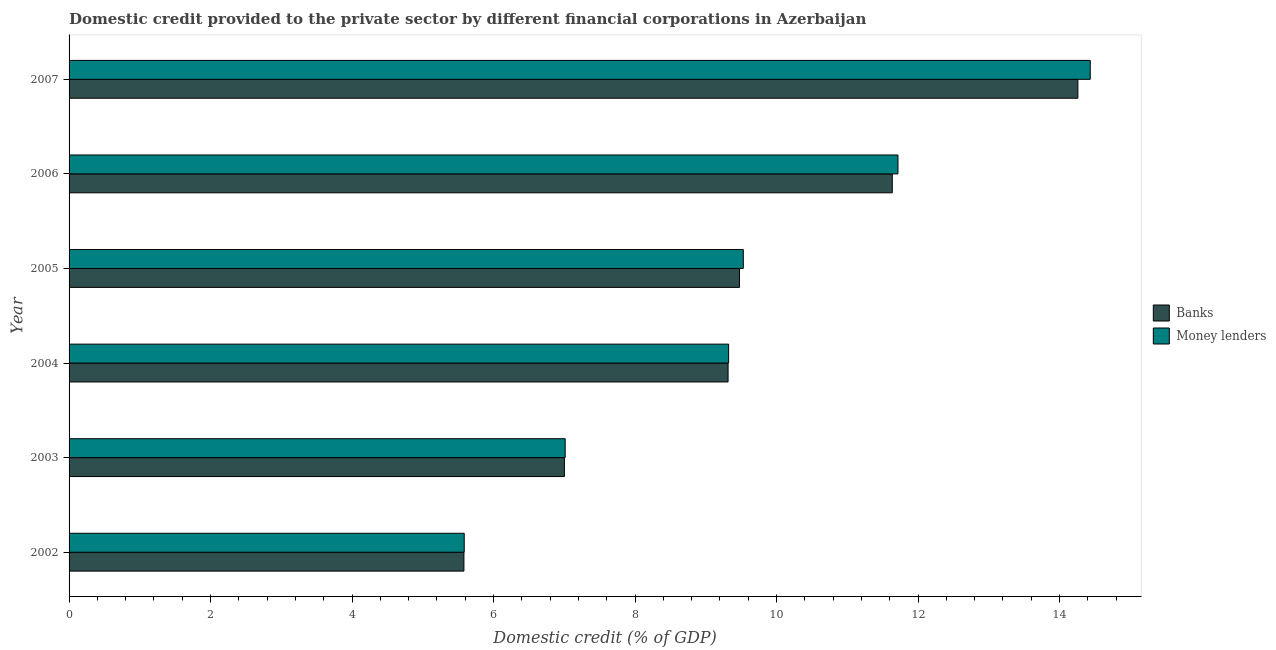How many groups of bars are there?
Provide a succinct answer. 6. Are the number of bars on each tick of the Y-axis equal?
Ensure brevity in your answer.  Yes. How many bars are there on the 3rd tick from the top?
Give a very brief answer. 2. In how many cases, is the number of bars for a given year not equal to the number of legend labels?
Your answer should be compact. 0. What is the domestic credit provided by money lenders in 2006?
Your answer should be very brief. 11.72. Across all years, what is the maximum domestic credit provided by banks?
Keep it short and to the point. 14.26. Across all years, what is the minimum domestic credit provided by money lenders?
Your answer should be very brief. 5.58. What is the total domestic credit provided by banks in the graph?
Offer a terse response. 57.27. What is the difference between the domestic credit provided by money lenders in 2002 and that in 2003?
Provide a short and direct response. -1.43. What is the difference between the domestic credit provided by banks in 2003 and the domestic credit provided by money lenders in 2006?
Give a very brief answer. -4.71. What is the average domestic credit provided by banks per year?
Give a very brief answer. 9.54. In the year 2003, what is the difference between the domestic credit provided by money lenders and domestic credit provided by banks?
Your answer should be very brief. 0.01. In how many years, is the domestic credit provided by money lenders greater than 2 %?
Your answer should be compact. 6. What is the ratio of the domestic credit provided by money lenders in 2003 to that in 2005?
Provide a succinct answer. 0.74. Is the difference between the domestic credit provided by banks in 2002 and 2006 greater than the difference between the domestic credit provided by money lenders in 2002 and 2006?
Provide a succinct answer. Yes. What is the difference between the highest and the second highest domestic credit provided by banks?
Your response must be concise. 2.62. What is the difference between the highest and the lowest domestic credit provided by banks?
Offer a terse response. 8.68. In how many years, is the domestic credit provided by money lenders greater than the average domestic credit provided by money lenders taken over all years?
Your answer should be compact. 2. Is the sum of the domestic credit provided by banks in 2002 and 2007 greater than the maximum domestic credit provided by money lenders across all years?
Offer a terse response. Yes. What does the 1st bar from the top in 2006 represents?
Make the answer very short. Money lenders. What does the 1st bar from the bottom in 2007 represents?
Your answer should be compact. Banks. How many bars are there?
Offer a very short reply. 12. How many years are there in the graph?
Your answer should be compact. 6. Are the values on the major ticks of X-axis written in scientific E-notation?
Offer a terse response. No. How many legend labels are there?
Offer a very short reply. 2. How are the legend labels stacked?
Ensure brevity in your answer.  Vertical. What is the title of the graph?
Your response must be concise. Domestic credit provided to the private sector by different financial corporations in Azerbaijan. What is the label or title of the X-axis?
Ensure brevity in your answer.  Domestic credit (% of GDP). What is the Domestic credit (% of GDP) of Banks in 2002?
Provide a short and direct response. 5.58. What is the Domestic credit (% of GDP) in Money lenders in 2002?
Ensure brevity in your answer.  5.58. What is the Domestic credit (% of GDP) of Banks in 2003?
Your answer should be compact. 7. What is the Domestic credit (% of GDP) in Money lenders in 2003?
Make the answer very short. 7.01. What is the Domestic credit (% of GDP) of Banks in 2004?
Your response must be concise. 9.31. What is the Domestic credit (% of GDP) of Money lenders in 2004?
Keep it short and to the point. 9.32. What is the Domestic credit (% of GDP) of Banks in 2005?
Give a very brief answer. 9.48. What is the Domestic credit (% of GDP) of Money lenders in 2005?
Make the answer very short. 9.53. What is the Domestic credit (% of GDP) in Banks in 2006?
Provide a short and direct response. 11.64. What is the Domestic credit (% of GDP) of Money lenders in 2006?
Provide a succinct answer. 11.72. What is the Domestic credit (% of GDP) in Banks in 2007?
Keep it short and to the point. 14.26. What is the Domestic credit (% of GDP) of Money lenders in 2007?
Your answer should be compact. 14.43. Across all years, what is the maximum Domestic credit (% of GDP) of Banks?
Your answer should be compact. 14.26. Across all years, what is the maximum Domestic credit (% of GDP) in Money lenders?
Your answer should be very brief. 14.43. Across all years, what is the minimum Domestic credit (% of GDP) of Banks?
Keep it short and to the point. 5.58. Across all years, what is the minimum Domestic credit (% of GDP) in Money lenders?
Your answer should be very brief. 5.58. What is the total Domestic credit (% of GDP) in Banks in the graph?
Your response must be concise. 57.27. What is the total Domestic credit (% of GDP) in Money lenders in the graph?
Your answer should be very brief. 57.6. What is the difference between the Domestic credit (% of GDP) in Banks in 2002 and that in 2003?
Ensure brevity in your answer.  -1.42. What is the difference between the Domestic credit (% of GDP) in Money lenders in 2002 and that in 2003?
Your answer should be compact. -1.43. What is the difference between the Domestic credit (% of GDP) in Banks in 2002 and that in 2004?
Ensure brevity in your answer.  -3.73. What is the difference between the Domestic credit (% of GDP) of Money lenders in 2002 and that in 2004?
Make the answer very short. -3.74. What is the difference between the Domestic credit (% of GDP) of Banks in 2002 and that in 2005?
Ensure brevity in your answer.  -3.89. What is the difference between the Domestic credit (% of GDP) in Money lenders in 2002 and that in 2005?
Provide a short and direct response. -3.94. What is the difference between the Domestic credit (% of GDP) in Banks in 2002 and that in 2006?
Your answer should be compact. -6.05. What is the difference between the Domestic credit (% of GDP) in Money lenders in 2002 and that in 2006?
Offer a very short reply. -6.13. What is the difference between the Domestic credit (% of GDP) of Banks in 2002 and that in 2007?
Ensure brevity in your answer.  -8.68. What is the difference between the Domestic credit (% of GDP) in Money lenders in 2002 and that in 2007?
Give a very brief answer. -8.85. What is the difference between the Domestic credit (% of GDP) of Banks in 2003 and that in 2004?
Make the answer very short. -2.31. What is the difference between the Domestic credit (% of GDP) of Money lenders in 2003 and that in 2004?
Ensure brevity in your answer.  -2.31. What is the difference between the Domestic credit (% of GDP) of Banks in 2003 and that in 2005?
Give a very brief answer. -2.47. What is the difference between the Domestic credit (% of GDP) of Money lenders in 2003 and that in 2005?
Give a very brief answer. -2.52. What is the difference between the Domestic credit (% of GDP) of Banks in 2003 and that in 2006?
Ensure brevity in your answer.  -4.63. What is the difference between the Domestic credit (% of GDP) of Money lenders in 2003 and that in 2006?
Offer a very short reply. -4.7. What is the difference between the Domestic credit (% of GDP) in Banks in 2003 and that in 2007?
Provide a short and direct response. -7.26. What is the difference between the Domestic credit (% of GDP) in Money lenders in 2003 and that in 2007?
Offer a very short reply. -7.42. What is the difference between the Domestic credit (% of GDP) of Banks in 2004 and that in 2005?
Offer a terse response. -0.16. What is the difference between the Domestic credit (% of GDP) of Money lenders in 2004 and that in 2005?
Make the answer very short. -0.21. What is the difference between the Domestic credit (% of GDP) of Banks in 2004 and that in 2006?
Keep it short and to the point. -2.32. What is the difference between the Domestic credit (% of GDP) in Money lenders in 2004 and that in 2006?
Make the answer very short. -2.39. What is the difference between the Domestic credit (% of GDP) of Banks in 2004 and that in 2007?
Offer a terse response. -4.94. What is the difference between the Domestic credit (% of GDP) of Money lenders in 2004 and that in 2007?
Provide a succinct answer. -5.11. What is the difference between the Domestic credit (% of GDP) of Banks in 2005 and that in 2006?
Your response must be concise. -2.16. What is the difference between the Domestic credit (% of GDP) of Money lenders in 2005 and that in 2006?
Ensure brevity in your answer.  -2.19. What is the difference between the Domestic credit (% of GDP) in Banks in 2005 and that in 2007?
Give a very brief answer. -4.78. What is the difference between the Domestic credit (% of GDP) in Money lenders in 2005 and that in 2007?
Your answer should be very brief. -4.9. What is the difference between the Domestic credit (% of GDP) in Banks in 2006 and that in 2007?
Offer a very short reply. -2.62. What is the difference between the Domestic credit (% of GDP) in Money lenders in 2006 and that in 2007?
Offer a terse response. -2.72. What is the difference between the Domestic credit (% of GDP) in Banks in 2002 and the Domestic credit (% of GDP) in Money lenders in 2003?
Give a very brief answer. -1.43. What is the difference between the Domestic credit (% of GDP) of Banks in 2002 and the Domestic credit (% of GDP) of Money lenders in 2004?
Make the answer very short. -3.74. What is the difference between the Domestic credit (% of GDP) in Banks in 2002 and the Domestic credit (% of GDP) in Money lenders in 2005?
Offer a terse response. -3.95. What is the difference between the Domestic credit (% of GDP) in Banks in 2002 and the Domestic credit (% of GDP) in Money lenders in 2006?
Give a very brief answer. -6.13. What is the difference between the Domestic credit (% of GDP) of Banks in 2002 and the Domestic credit (% of GDP) of Money lenders in 2007?
Offer a terse response. -8.85. What is the difference between the Domestic credit (% of GDP) in Banks in 2003 and the Domestic credit (% of GDP) in Money lenders in 2004?
Your answer should be compact. -2.32. What is the difference between the Domestic credit (% of GDP) in Banks in 2003 and the Domestic credit (% of GDP) in Money lenders in 2005?
Your response must be concise. -2.53. What is the difference between the Domestic credit (% of GDP) of Banks in 2003 and the Domestic credit (% of GDP) of Money lenders in 2006?
Provide a succinct answer. -4.71. What is the difference between the Domestic credit (% of GDP) of Banks in 2003 and the Domestic credit (% of GDP) of Money lenders in 2007?
Provide a short and direct response. -7.43. What is the difference between the Domestic credit (% of GDP) in Banks in 2004 and the Domestic credit (% of GDP) in Money lenders in 2005?
Provide a succinct answer. -0.22. What is the difference between the Domestic credit (% of GDP) in Banks in 2004 and the Domestic credit (% of GDP) in Money lenders in 2006?
Offer a very short reply. -2.4. What is the difference between the Domestic credit (% of GDP) of Banks in 2004 and the Domestic credit (% of GDP) of Money lenders in 2007?
Offer a terse response. -5.12. What is the difference between the Domestic credit (% of GDP) of Banks in 2005 and the Domestic credit (% of GDP) of Money lenders in 2006?
Provide a succinct answer. -2.24. What is the difference between the Domestic credit (% of GDP) of Banks in 2005 and the Domestic credit (% of GDP) of Money lenders in 2007?
Your answer should be very brief. -4.96. What is the difference between the Domestic credit (% of GDP) of Banks in 2006 and the Domestic credit (% of GDP) of Money lenders in 2007?
Keep it short and to the point. -2.8. What is the average Domestic credit (% of GDP) in Banks per year?
Your response must be concise. 9.54. What is the average Domestic credit (% of GDP) of Money lenders per year?
Make the answer very short. 9.6. In the year 2002, what is the difference between the Domestic credit (% of GDP) in Banks and Domestic credit (% of GDP) in Money lenders?
Your response must be concise. -0. In the year 2003, what is the difference between the Domestic credit (% of GDP) in Banks and Domestic credit (% of GDP) in Money lenders?
Your answer should be compact. -0.01. In the year 2004, what is the difference between the Domestic credit (% of GDP) in Banks and Domestic credit (% of GDP) in Money lenders?
Keep it short and to the point. -0.01. In the year 2005, what is the difference between the Domestic credit (% of GDP) of Banks and Domestic credit (% of GDP) of Money lenders?
Make the answer very short. -0.05. In the year 2006, what is the difference between the Domestic credit (% of GDP) of Banks and Domestic credit (% of GDP) of Money lenders?
Your answer should be compact. -0.08. In the year 2007, what is the difference between the Domestic credit (% of GDP) in Banks and Domestic credit (% of GDP) in Money lenders?
Make the answer very short. -0.17. What is the ratio of the Domestic credit (% of GDP) in Banks in 2002 to that in 2003?
Offer a very short reply. 0.8. What is the ratio of the Domestic credit (% of GDP) of Money lenders in 2002 to that in 2003?
Provide a short and direct response. 0.8. What is the ratio of the Domestic credit (% of GDP) of Banks in 2002 to that in 2004?
Ensure brevity in your answer.  0.6. What is the ratio of the Domestic credit (% of GDP) in Money lenders in 2002 to that in 2004?
Keep it short and to the point. 0.6. What is the ratio of the Domestic credit (% of GDP) of Banks in 2002 to that in 2005?
Ensure brevity in your answer.  0.59. What is the ratio of the Domestic credit (% of GDP) in Money lenders in 2002 to that in 2005?
Make the answer very short. 0.59. What is the ratio of the Domestic credit (% of GDP) of Banks in 2002 to that in 2006?
Offer a very short reply. 0.48. What is the ratio of the Domestic credit (% of GDP) in Money lenders in 2002 to that in 2006?
Offer a very short reply. 0.48. What is the ratio of the Domestic credit (% of GDP) in Banks in 2002 to that in 2007?
Offer a very short reply. 0.39. What is the ratio of the Domestic credit (% of GDP) of Money lenders in 2002 to that in 2007?
Provide a succinct answer. 0.39. What is the ratio of the Domestic credit (% of GDP) in Banks in 2003 to that in 2004?
Ensure brevity in your answer.  0.75. What is the ratio of the Domestic credit (% of GDP) in Money lenders in 2003 to that in 2004?
Keep it short and to the point. 0.75. What is the ratio of the Domestic credit (% of GDP) of Banks in 2003 to that in 2005?
Give a very brief answer. 0.74. What is the ratio of the Domestic credit (% of GDP) in Money lenders in 2003 to that in 2005?
Give a very brief answer. 0.74. What is the ratio of the Domestic credit (% of GDP) in Banks in 2003 to that in 2006?
Make the answer very short. 0.6. What is the ratio of the Domestic credit (% of GDP) in Money lenders in 2003 to that in 2006?
Your answer should be compact. 0.6. What is the ratio of the Domestic credit (% of GDP) in Banks in 2003 to that in 2007?
Provide a succinct answer. 0.49. What is the ratio of the Domestic credit (% of GDP) in Money lenders in 2003 to that in 2007?
Offer a terse response. 0.49. What is the ratio of the Domestic credit (% of GDP) in Money lenders in 2004 to that in 2005?
Offer a terse response. 0.98. What is the ratio of the Domestic credit (% of GDP) of Banks in 2004 to that in 2006?
Offer a very short reply. 0.8. What is the ratio of the Domestic credit (% of GDP) of Money lenders in 2004 to that in 2006?
Offer a very short reply. 0.8. What is the ratio of the Domestic credit (% of GDP) in Banks in 2004 to that in 2007?
Ensure brevity in your answer.  0.65. What is the ratio of the Domestic credit (% of GDP) of Money lenders in 2004 to that in 2007?
Your response must be concise. 0.65. What is the ratio of the Domestic credit (% of GDP) of Banks in 2005 to that in 2006?
Keep it short and to the point. 0.81. What is the ratio of the Domestic credit (% of GDP) in Money lenders in 2005 to that in 2006?
Keep it short and to the point. 0.81. What is the ratio of the Domestic credit (% of GDP) in Banks in 2005 to that in 2007?
Offer a very short reply. 0.66. What is the ratio of the Domestic credit (% of GDP) in Money lenders in 2005 to that in 2007?
Your answer should be very brief. 0.66. What is the ratio of the Domestic credit (% of GDP) in Banks in 2006 to that in 2007?
Your answer should be compact. 0.82. What is the ratio of the Domestic credit (% of GDP) of Money lenders in 2006 to that in 2007?
Keep it short and to the point. 0.81. What is the difference between the highest and the second highest Domestic credit (% of GDP) in Banks?
Make the answer very short. 2.62. What is the difference between the highest and the second highest Domestic credit (% of GDP) of Money lenders?
Ensure brevity in your answer.  2.72. What is the difference between the highest and the lowest Domestic credit (% of GDP) in Banks?
Provide a succinct answer. 8.68. What is the difference between the highest and the lowest Domestic credit (% of GDP) in Money lenders?
Give a very brief answer. 8.85. 